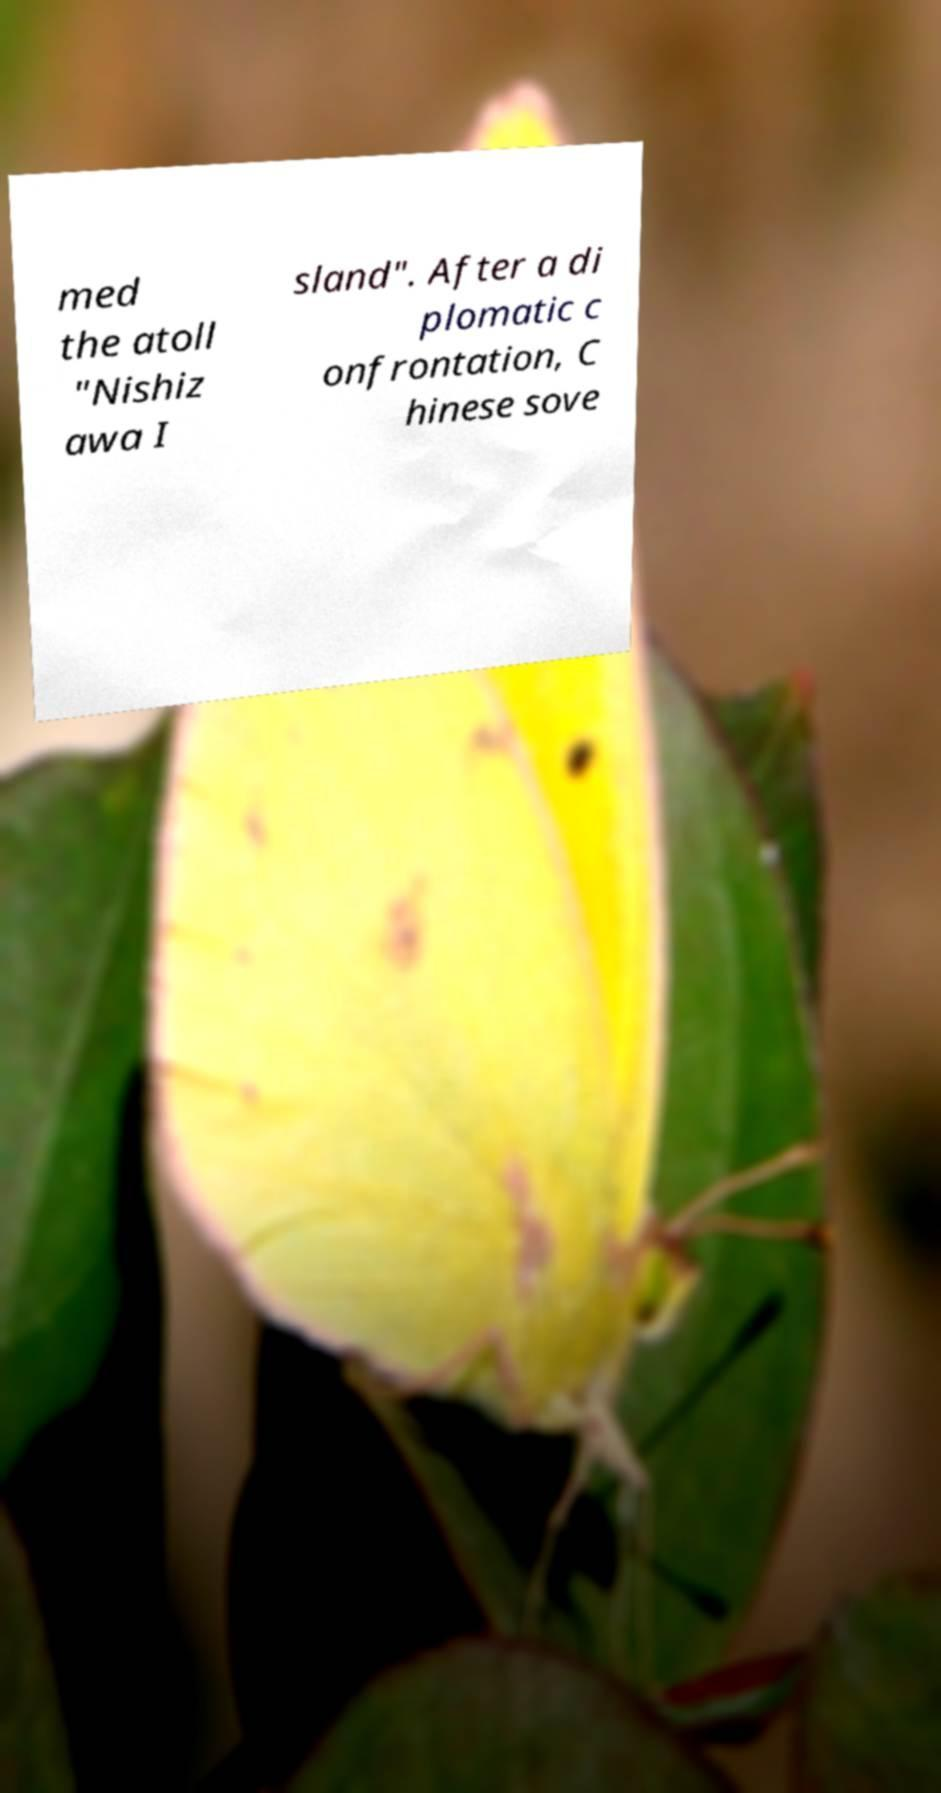Could you extract and type out the text from this image? med the atoll "Nishiz awa I sland". After a di plomatic c onfrontation, C hinese sove 